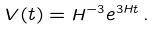Convert formula to latex. <formula><loc_0><loc_0><loc_500><loc_500>V ( t ) = H ^ { - 3 } e ^ { 3 H t } \, .</formula> 